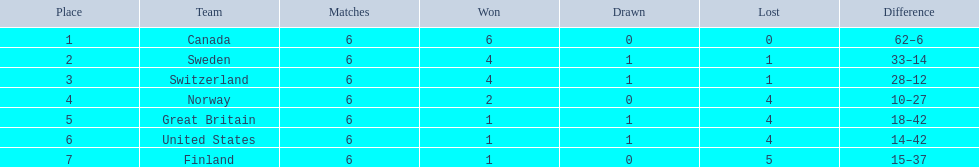What are all the teams? Canada, Sweden, Switzerland, Norway, Great Britain, United States, Finland. What were their points? 12, 9, 9, 4, 3, 3, 2. What about just switzerland and great britain? 9, 3. Now, which of those teams scored higher? Switzerland. 